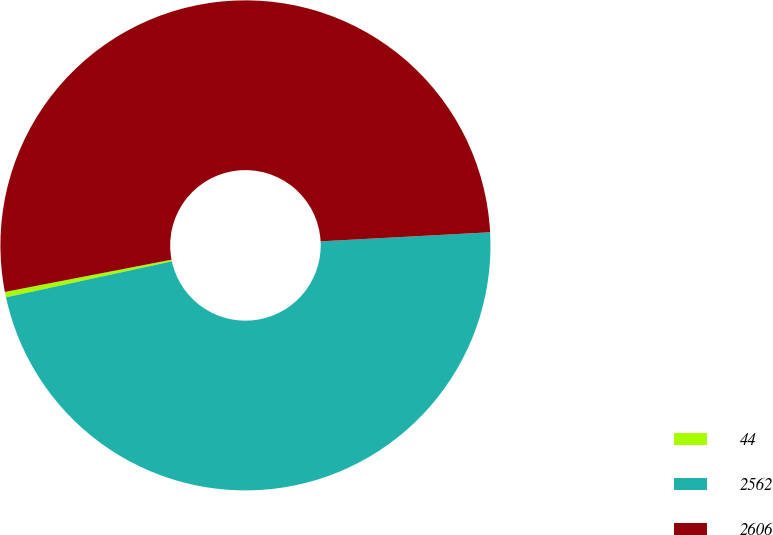Convert chart to OTSL. <chart><loc_0><loc_0><loc_500><loc_500><pie_chart><fcel>44<fcel>2562<fcel>2606<nl><fcel>0.36%<fcel>47.45%<fcel>52.19%<nl></chart> 